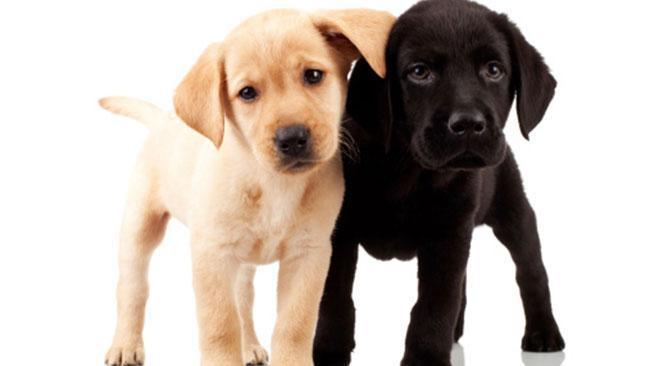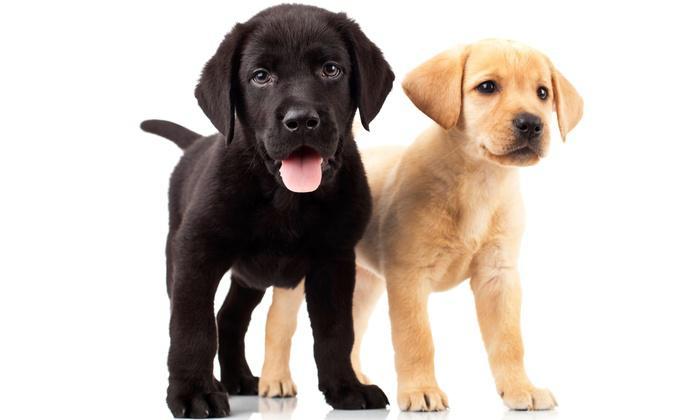The first image is the image on the left, the second image is the image on the right. For the images displayed, is the sentence "An image shows a row of three dogs, with a black one in the middle." factually correct? Answer yes or no. No. The first image is the image on the left, the second image is the image on the right. Assess this claim about the two images: "There are four dogs.". Correct or not? Answer yes or no. Yes. 